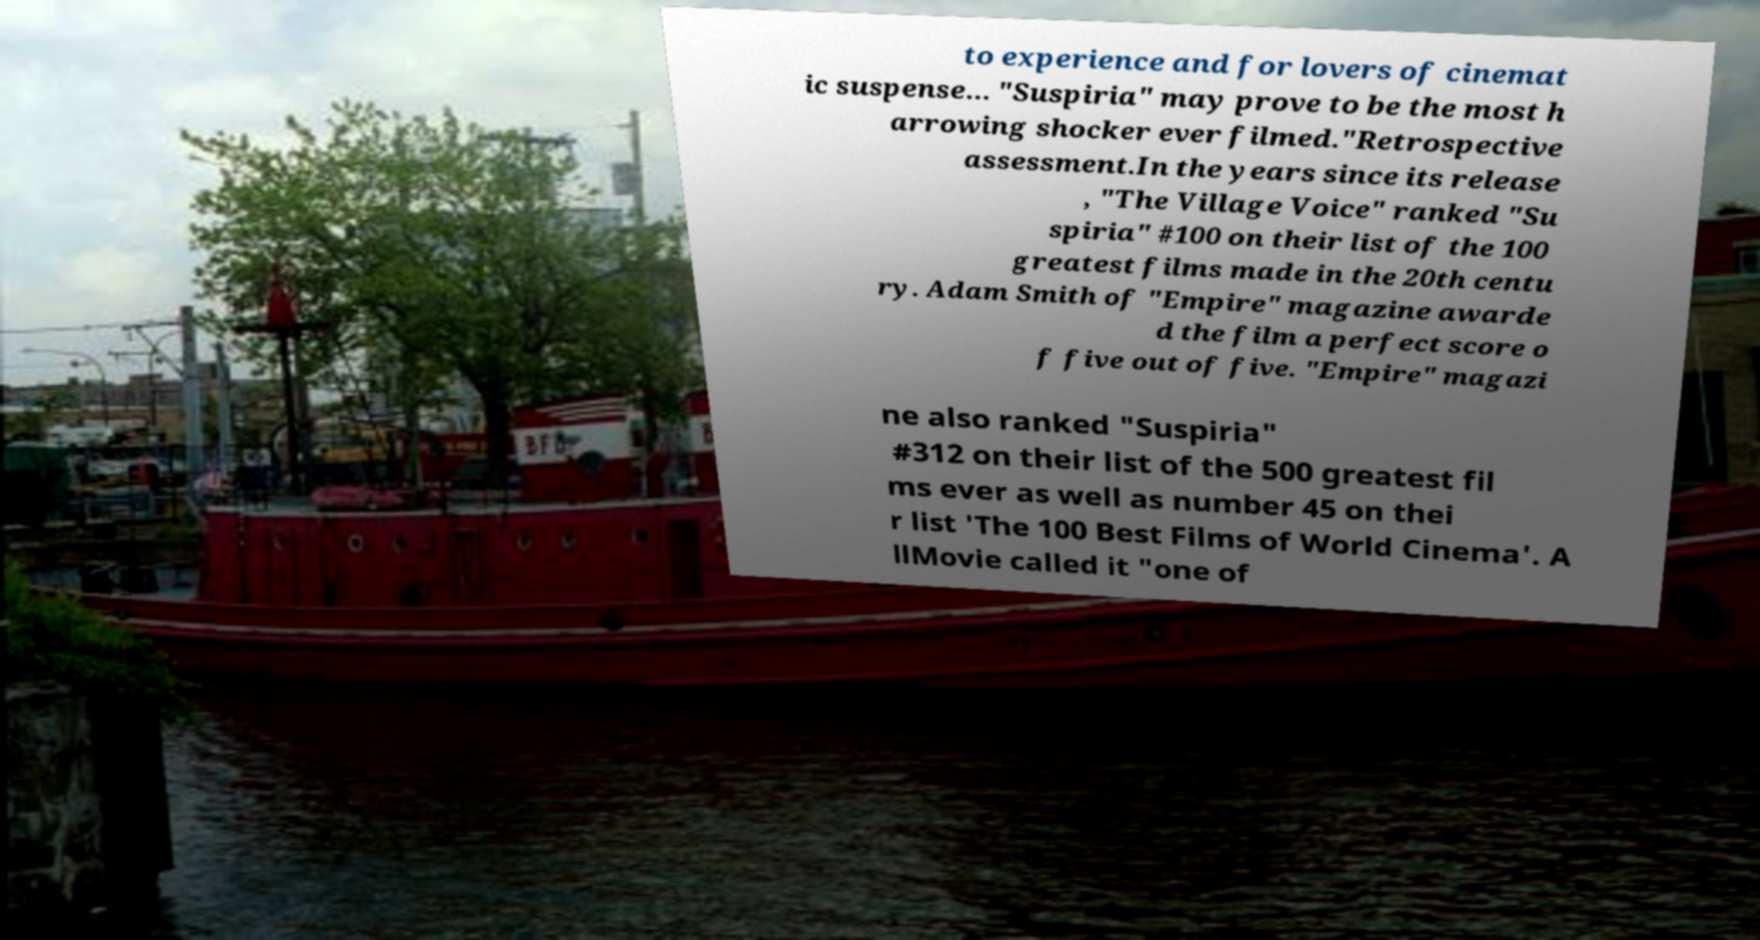Could you extract and type out the text from this image? to experience and for lovers of cinemat ic suspense... "Suspiria" may prove to be the most h arrowing shocker ever filmed."Retrospective assessment.In the years since its release , "The Village Voice" ranked "Su spiria" #100 on their list of the 100 greatest films made in the 20th centu ry. Adam Smith of "Empire" magazine awarde d the film a perfect score o f five out of five. "Empire" magazi ne also ranked "Suspiria" #312 on their list of the 500 greatest fil ms ever as well as number 45 on thei r list 'The 100 Best Films of World Cinema'. A llMovie called it "one of 